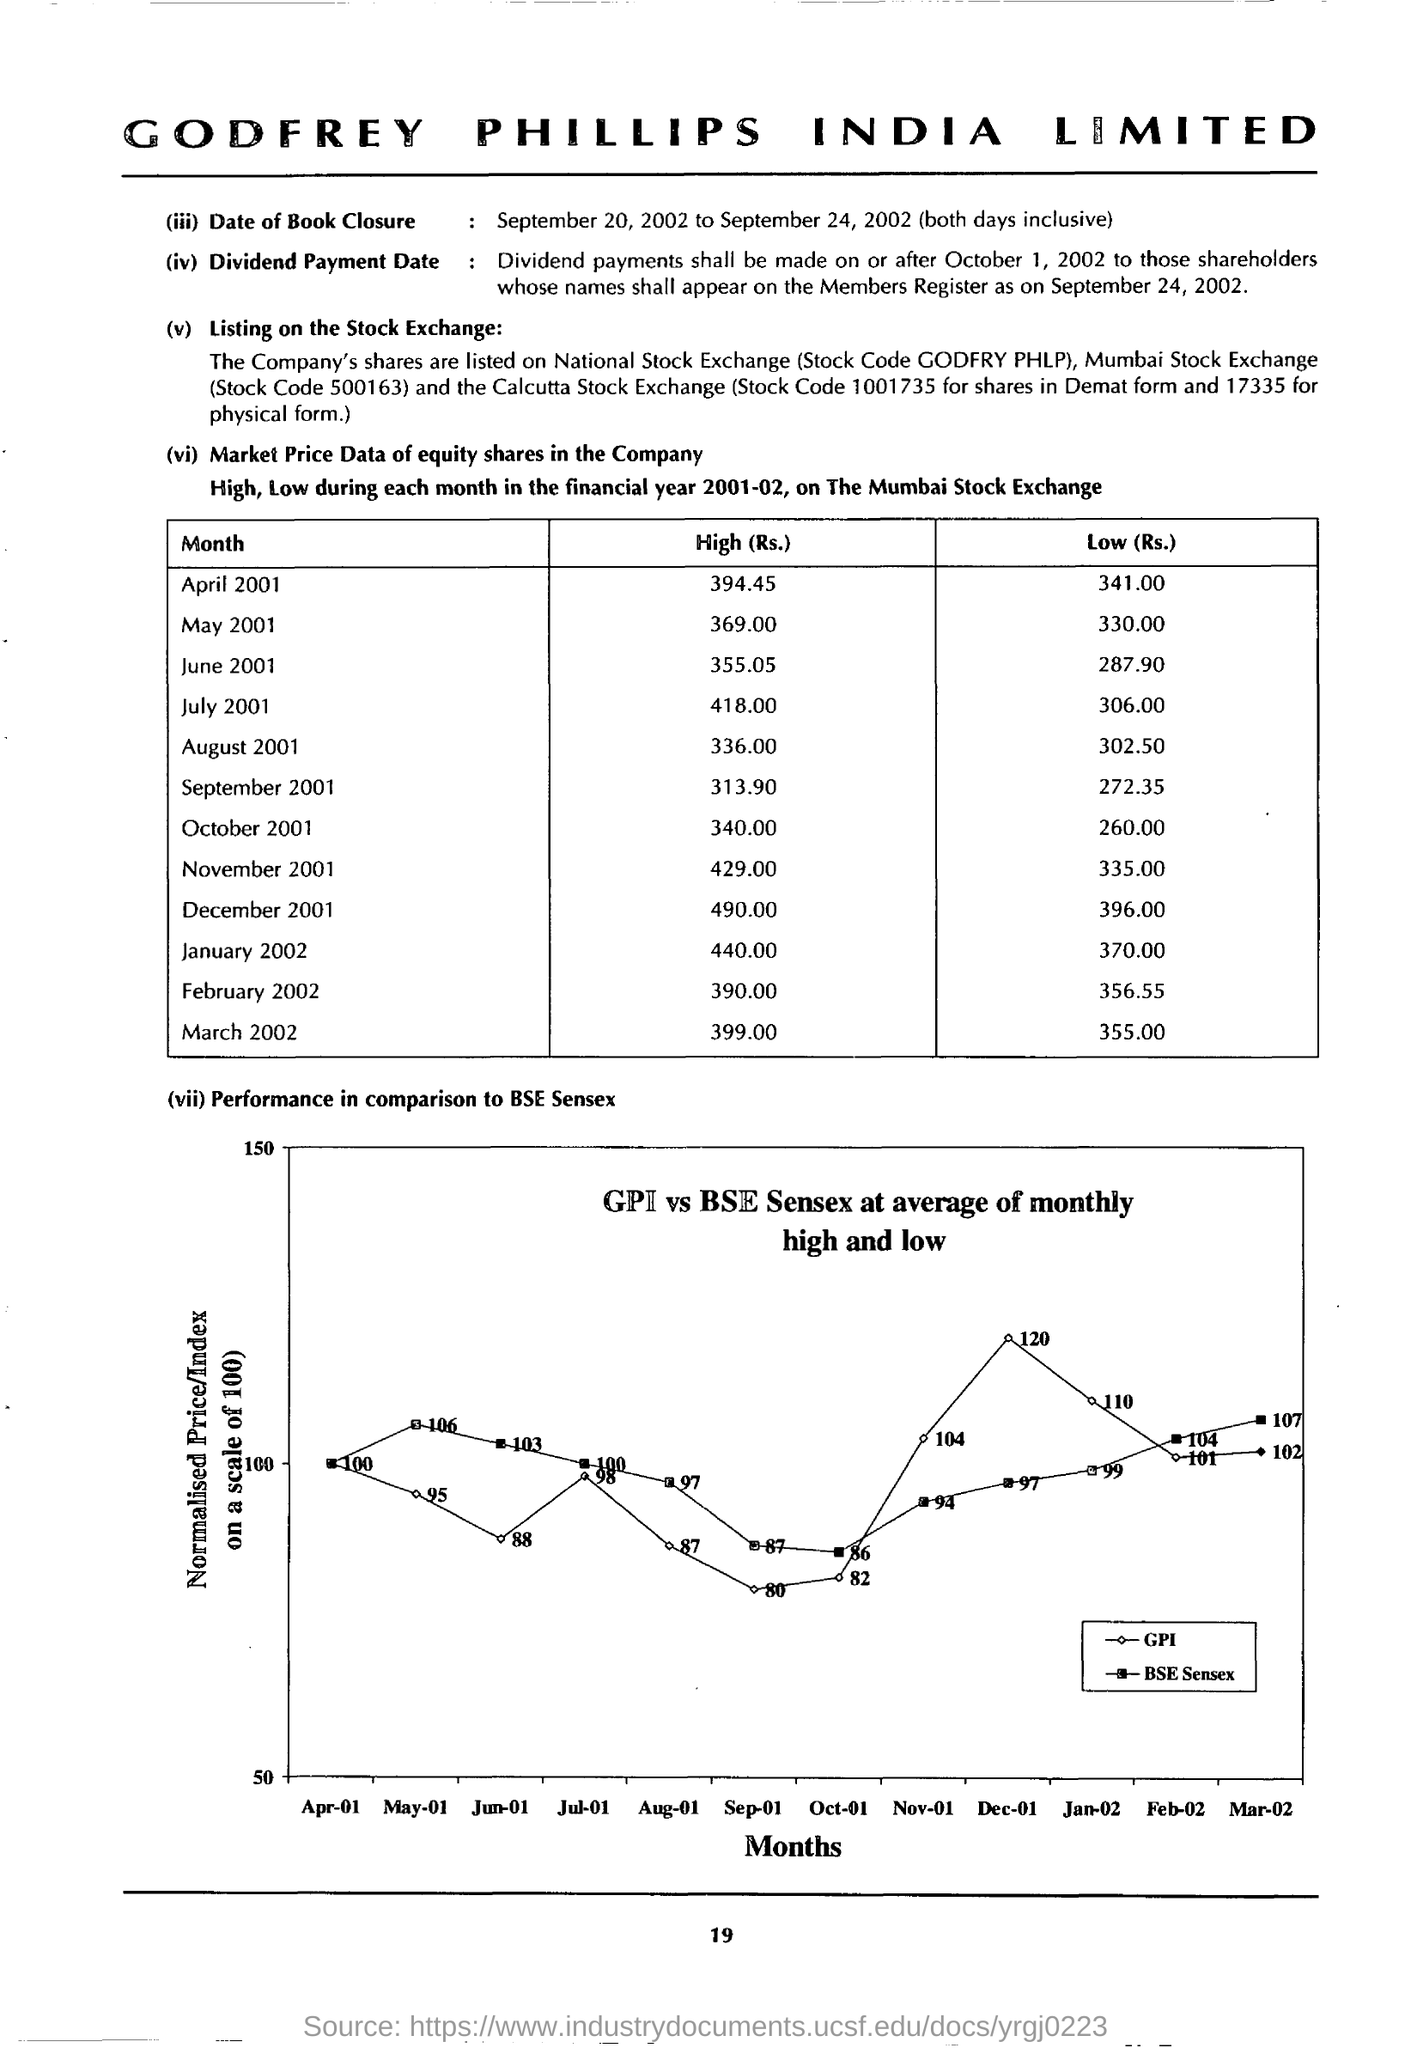Give some essential details in this illustration. The Y-axis of the graph describes the performance in comparison to the BSE Sensex, normalized price/index on a scale of 100. The X-axis of the graph represents the comparison of the performance to the BSE Sensex in terms of months. 